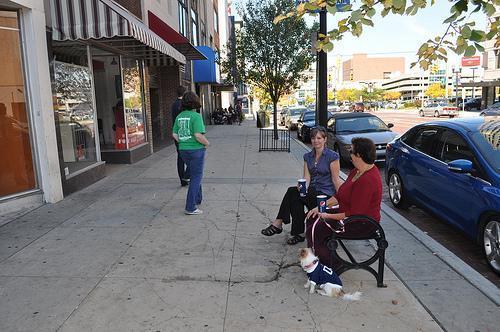How many people are visible?
Give a very brief answer. 4. How many people are sitting on the bench?
Give a very brief answer. 2. 